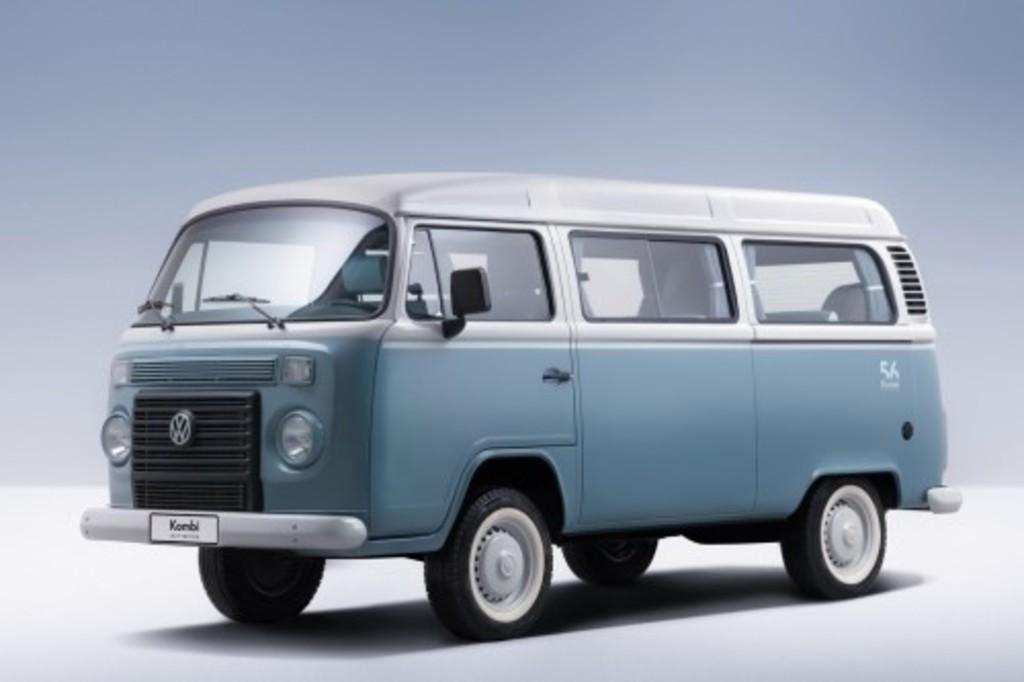<image>
Describe the image concisely. A blue Volkswagen van bears a difficult to discern logo starting with the letter K. 